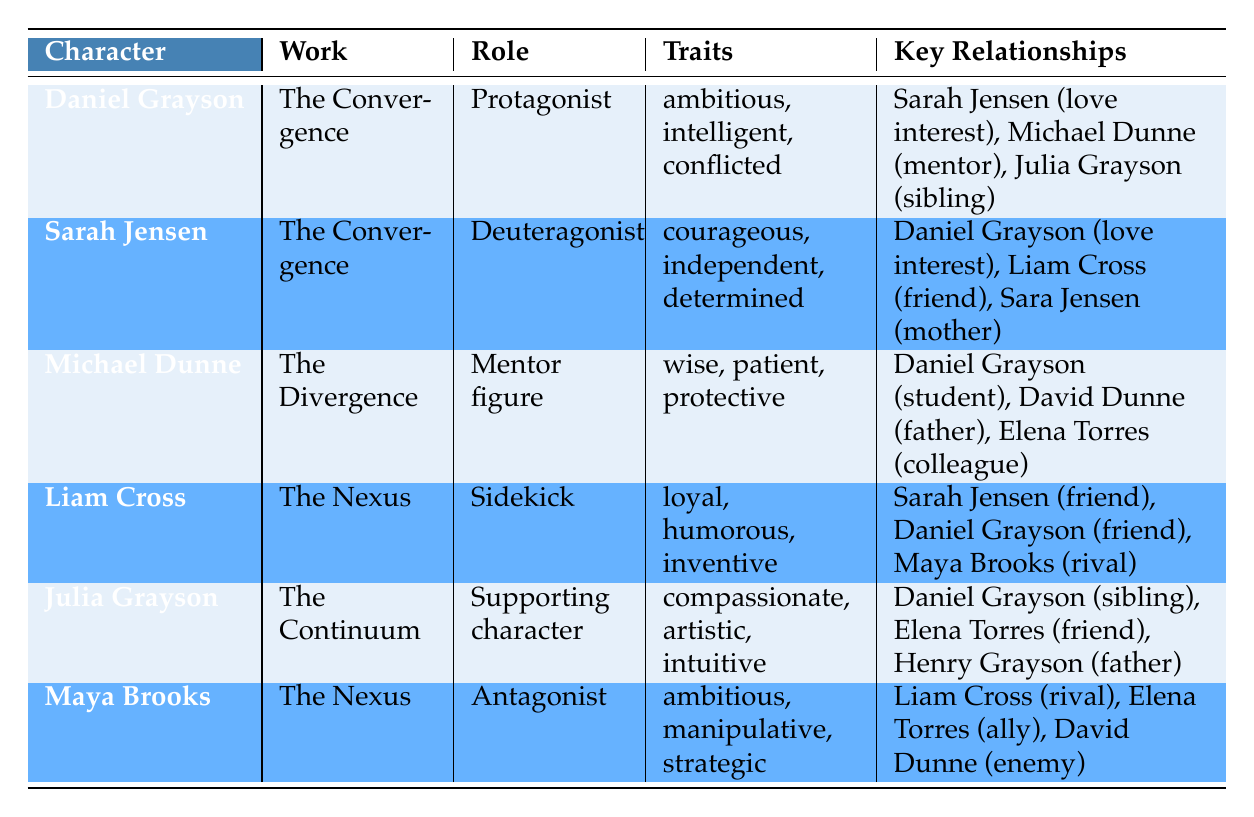What is the role of Daniel Grayson in "The Convergence"? From the table, we can see that Daniel Grayson is listed under the "Role" column for "The Convergence," indicating that he is the Protagonist in that work.
Answer: Protagonist Who is Sarah Jensen's mother according to the table? The relationships of Sarah Jensen are listed in the table. The entry indicates that her mother is Sara Jensen, as the relationship shows "mother" in the relationship type.
Answer: Sara Jensen Which character has a "complicated" love interest status with Daniel Grayson? By looking at the relationships for Daniel Grayson, it shows that he has a "complicated" love interest status with Sarah Jensen, as indicated in the relationship type.
Answer: Sarah Jensen How many characters are presented as a mentor figure in the table? There is one character displayed in the table identified as a mentor figure, which is Michael Dunne, as specified under the "Role" column.
Answer: 1 Are there any characters that share a sibling relationship with Daniel Grayson? The table indicates that Julia Grayson is listed as a sibling with a supportive status regarding Daniel Grayson, confirming that the fact is true.
Answer: Yes Which character is both a friend and has a trusting relationship with Sarah Jensen? In the table, Liam Cross is listed as a friend of Sarah Jensen with a "trusting" status, fulfilling the criteria asked.
Answer: Liam Cross What is the relationship type and status between Michael Dunne and Daniel Grayson? The table shows that Michael Dunne has a relationship type of "mentor" with Daniel Grayson and a status of "respected", combining both pieces of information from the relevant row in the table.
Answer: Mentor, respected Identify the antagonist character in "The Nexus." According to the details in the table, Maya Brooks is labeled as the Antagonist in "The Nexus", as shown under the "Role" column specifically for her name entry.
Answer: Maya Brooks What is the total number of friend relationships involving Liam Cross? In the relationships listed for Liam Cross, he has two friends: Sarah Jensen and Daniel Grayson. Summing these up gives a total of 2 friend relationships.
Answer: 2 Which character has the trait "artistic"? The table lists Julia Grayson as having the trait "artistic", which identifies her as the character in question.
Answer: Julia Grayson 